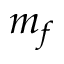<formula> <loc_0><loc_0><loc_500><loc_500>m _ { f }</formula> 